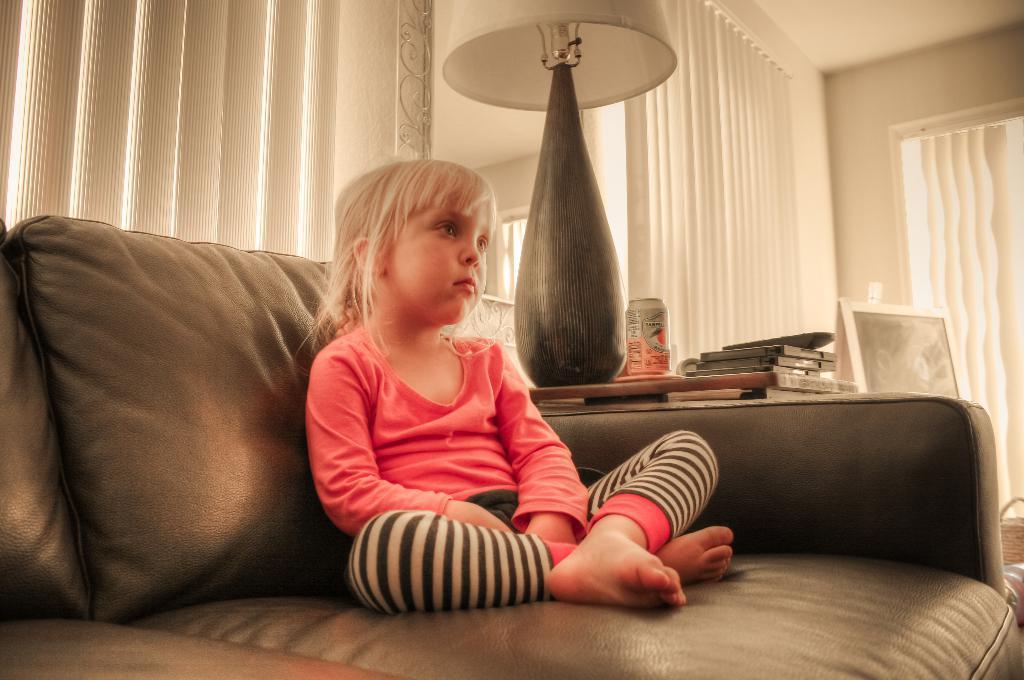Can you describe this image briefly? In this picture there is a girl who is sitting on the sofa there is a lamp at the center of the image and some books on the desk there are curtains around the area of the image. 